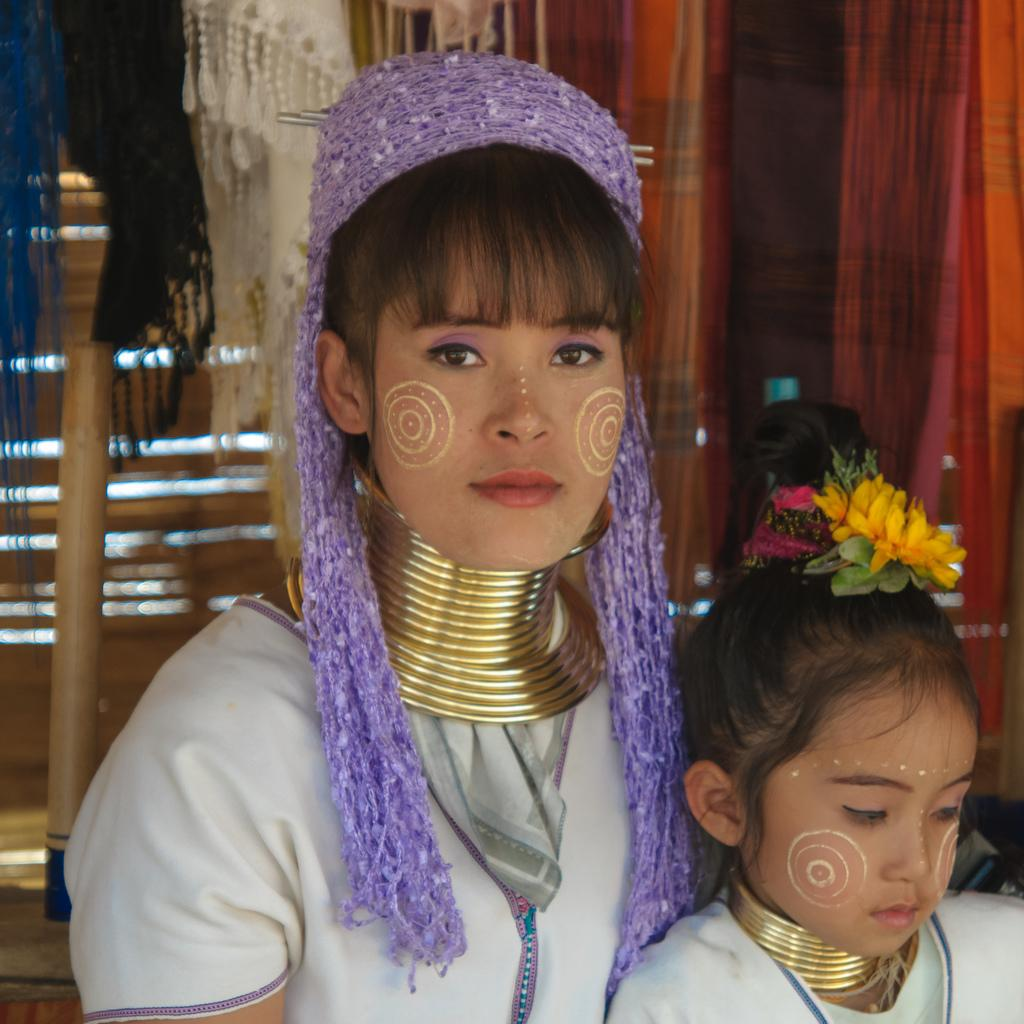How many people are in the image? There are two persons in the center of the image. What can be seen in the background of the image? There are clothes and a wall visible in the background of the image. What is at the bottom left corner of the image? There is a floor at the bottom left corner of the image. What type of popcorn can be seen in the hands of the boys in the image? There are no boys or popcorn present in the image. How many balls are visible in the image? There are no balls visible in the image. 